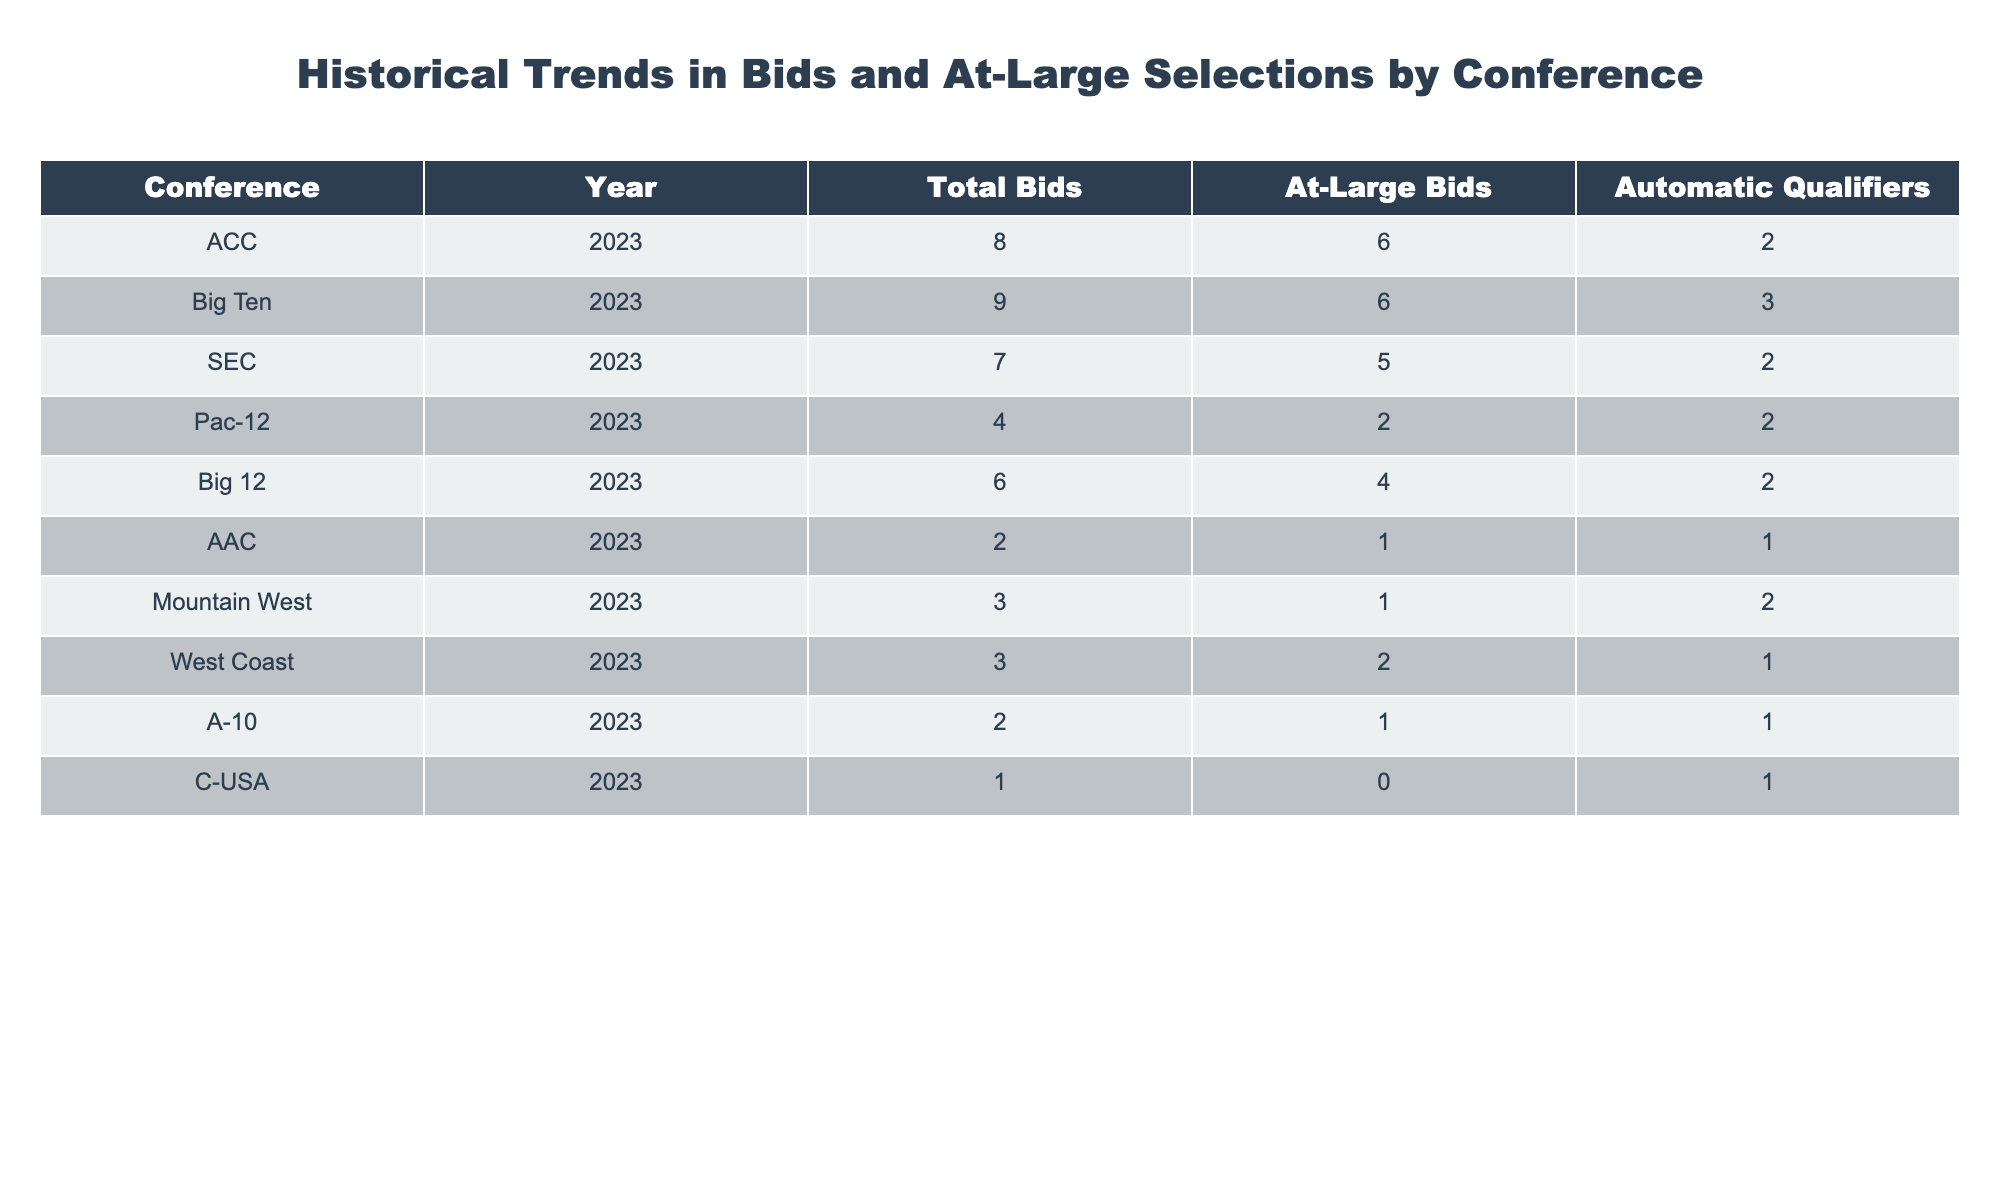What is the total number of bids for the ACC in 2023? Referring to the table, the ACC has a total of 8 bids listed for the year 2023 in the "Total Bids" column.
Answer: 8 How many at-large bids did the Big Ten receive in 2023? According to the table, the Big Ten received 6 at-large bids in 2023, as shown in the "At-Large Bids" column.
Answer: 6 Which conference secured the highest number of total bids in 2023? Looking across the "Total Bids" column, the Big Ten has the highest count with 9 total bids in 2023, surpassing all other conferences.
Answer: Big Ten Did the Pac-12 receive more automatic qualifiers than the AAC in 2023? The Pac-12 received 2 automatic qualifiers, while the AAC received 1 automatic qualifier in 2023, so the Pac-12 had more.
Answer: Yes What is the difference between the total bids and automatic qualifiers for the SEC in 2023? For the SEC, the total bids are 7 and the automatic qualifiers are 2. The difference is 7 - 2 = 5.
Answer: 5 Which conference had the least amount of total bids in 2023? By comparing the "Total Bids" numbers, C-USA has 1 total bid in 2023, which is the least among all listed conferences.
Answer: C-USA What is the average number of at-large bids received by the five conferences with the fewest bids? The five conferences with the fewest bids and their at-large bids are AAC (1), Mountain West (1), West Coast (2), A-10 (1), and C-USA (0). The average of these values is (1 + 1 + 2 + 1 + 0) / 5 = 1.
Answer: 1 Did any conference receive all its bids as automatic qualifiers in 2023? Referring to the table, C-USA received 1 total bid, which was an automatic qualifier, indicating that they did not have any at-large bids.
Answer: Yes What is the total number of automatic qualifiers for the Big 12 and the Pac-12 in 2023 combined? The Big 12 has 2 automatic qualifiers and the Pac-12 has 2 as well. Combining these totals gives us 2 + 2 = 4.
Answer: 4 How many bids did conferences from the Power Five collectively receive in 2023? The Power Five conferences are ACC (8), Big Ten (9), SEC (7), Pac-12 (4), and Big 12 (6). Summing these gives 8 + 9 + 7 + 4 + 6 = 34 bids collectively.
Answer: 34 